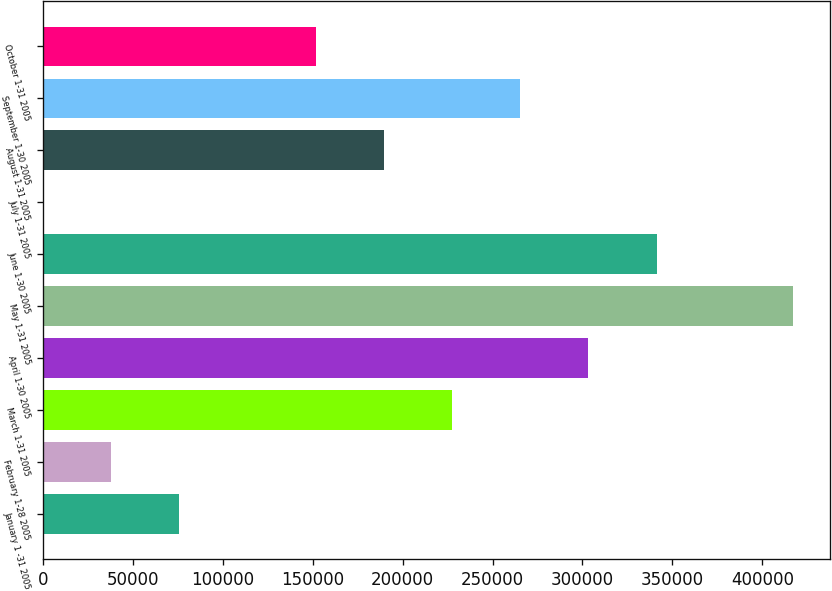Convert chart to OTSL. <chart><loc_0><loc_0><loc_500><loc_500><bar_chart><fcel>January 1 -31 2005<fcel>February 1-28 2005<fcel>March 1-31 2005<fcel>April 1-30 2005<fcel>May 1-31 2005<fcel>June 1-30 2005<fcel>July 1-31 2005<fcel>August 1-31 2005<fcel>September 1-30 2005<fcel>October 1-31 2005<nl><fcel>75834.6<fcel>37917.4<fcel>227503<fcel>303338<fcel>417089<fcel>341255<fcel>0.21<fcel>189586<fcel>265420<fcel>151669<nl></chart> 